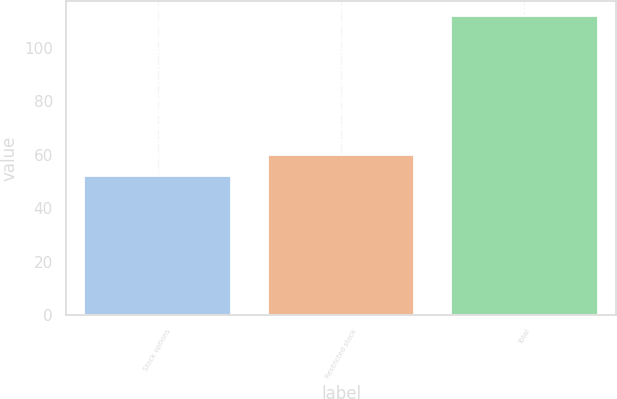<chart> <loc_0><loc_0><loc_500><loc_500><bar_chart><fcel>Stock options<fcel>Restricted stock<fcel>Total<nl><fcel>52<fcel>60<fcel>112<nl></chart> 